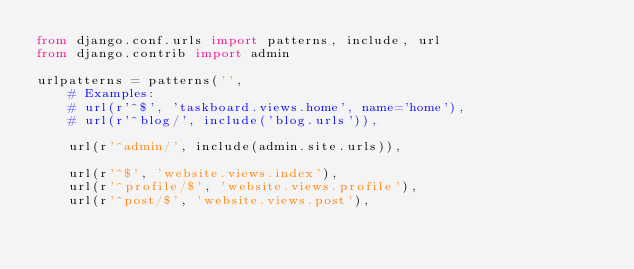Convert code to text. <code><loc_0><loc_0><loc_500><loc_500><_Python_>from django.conf.urls import patterns, include, url
from django.contrib import admin

urlpatterns = patterns('',
    # Examples:
    # url(r'^$', 'taskboard.views.home', name='home'),
    # url(r'^blog/', include('blog.urls')),

    url(r'^admin/', include(admin.site.urls)),

    url(r'^$', 'website.views.index'),
    url(r'^profile/$', 'website.views.profile'),
    url(r'^post/$', 'website.views.post'),</code> 